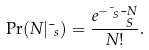<formula> <loc_0><loc_0><loc_500><loc_500>\Pr ( N | \mu _ { s } ) = \frac { e ^ { - \mu _ { S } } \mu _ { S } ^ { N } } { N ! } .</formula> 